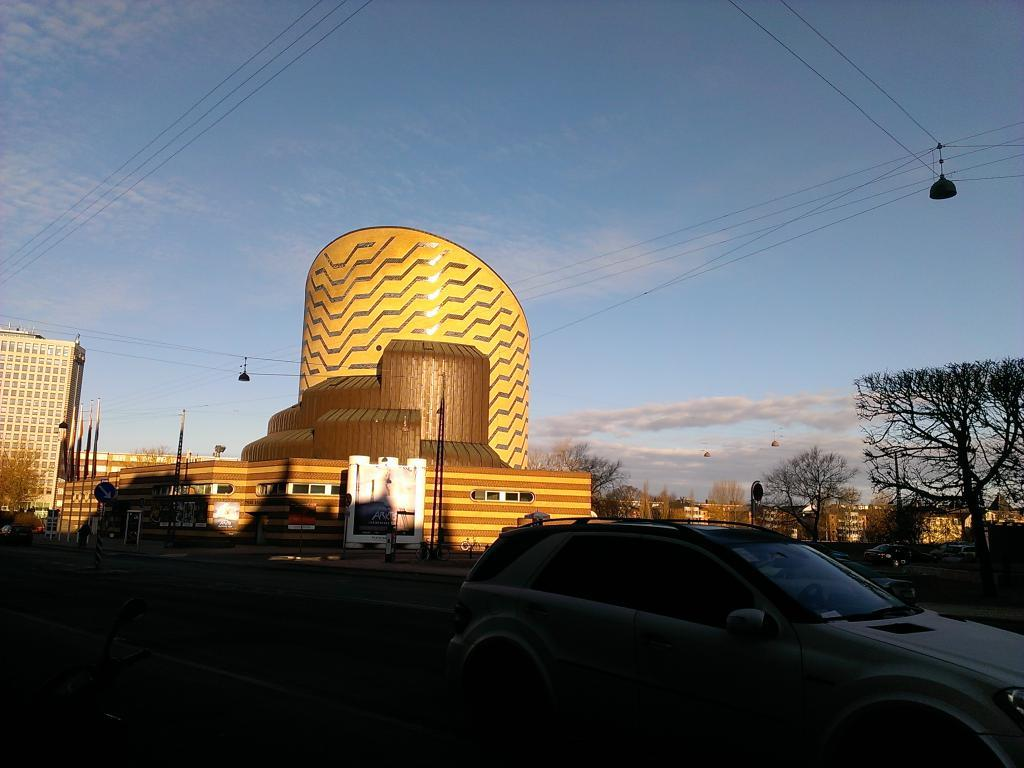What type of structures can be seen in the image? There are many buildings in the image. What other elements can be found in the image besides buildings? There are trees in the image. Is there any transportation visible in the image? Yes, there is a car parked on the road in the image. How many pigs are running down the middle of the road in the image? There are no pigs present in the image, and therefore none are running down the middle of the road. 